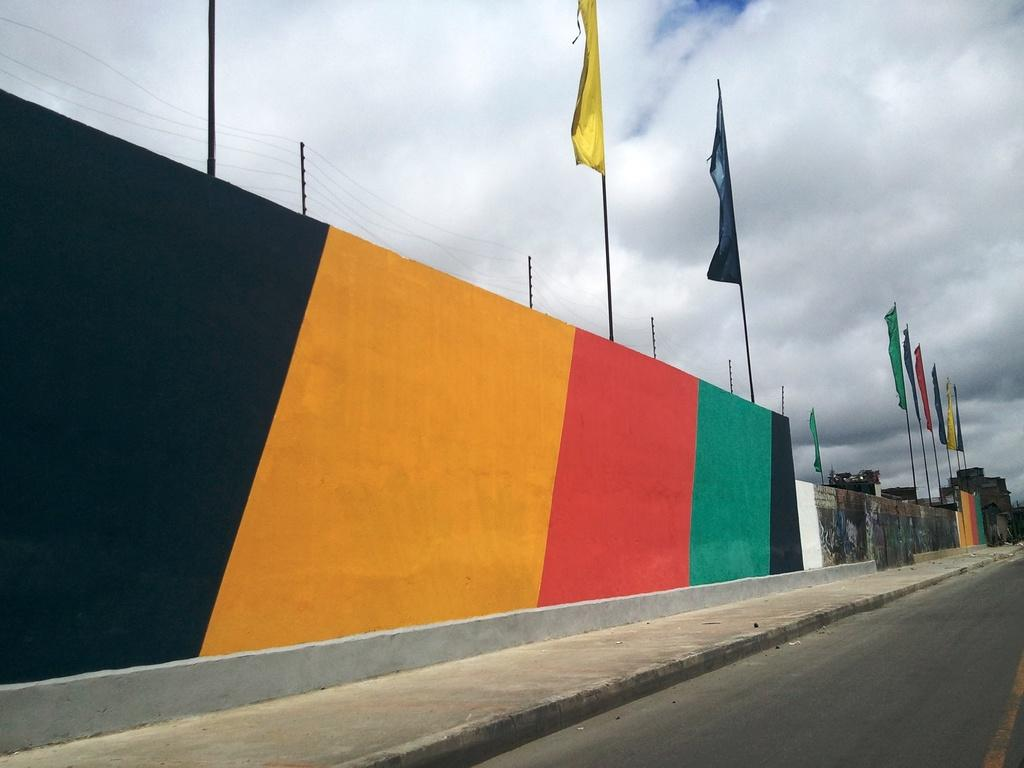What is present on the wall in the image? The wall has flags on it. What other structures can be seen in the image? There is a fence in the image. What is visible in the background of the image? The sky is visible in the background of the image. What type of pathway is present in the image? There is a road in the image. Where is the crib located in the image? There is no crib present in the image. What type of kite can be seen flying in the sky in the image? There is no kite visible in the sky in the image. 